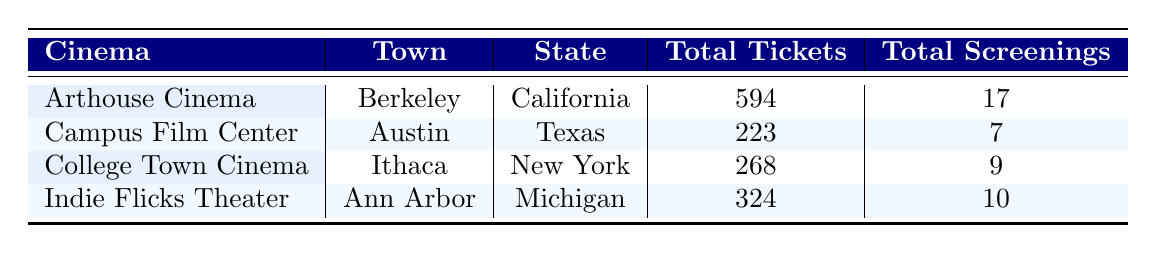What is the total number of tickets sold at Arthouse Cinema? The table shows that Arthouse Cinema sold a total of 594 tickets. This value is directly listed in the table under the "Total Tickets" column for Arthouse Cinema.
Answer: 594 Which cinema had the highest total screenings? By comparing the "Total Screenings" for each cinema, Arthouse Cinema in Berkeley has 17 total screenings, which is higher than the others (Campus Film Center: 7, College Town Cinema: 9, Indie Flicks Theater: 10). Therefore, it had the highest number of screenings.
Answer: Arthouse Cinema How many tickets were sold at Indie Flicks Theater? The table indicates that Indie Flicks Theater sold a total of 324 tickets. This value is found in the "Total Tickets" column corresponding to Indie Flicks Theater.
Answer: 324 What is the average number of tickets sold per screening at College Town Cinema? The average can be calculated by dividing the total tickets sold (268) by the total screenings (9) at College Town Cinema. So the average tickets sold per screening is 268 / 9 = 29.78, which we can round to 30.
Answer: 30 Is the total number of tickets sold at Campus Film Center greater than at Indie Flicks Theater? By checking the total tickets sold, Campus Film Center sold 223 tickets while Indie Flicks Theater sold 324 tickets. Hence, this statement is false.
Answer: No What is the combined total of tickets sold at all cinemas? The total can be calculated by adding the tickets sold at each cinema: 594 (Arthouse) + 223 (Campus) + 268 (College Town) + 324 (Indie Flicks) = 1409. Therefore, the combined total of tickets sold at all cinemas is 1409.
Answer: 1409 Which town has the least total screenings among the cinemas listed? By comparing the total screenings: Ann Arbor (10), Berkeley (17), Austin (7), and Ithaca (9), Austin has the least with 7 screenings.
Answer: Austin Is there a cinema in the state of New York? Yes, the table shows that College Town Cinema is located in Ithaca, New York. Thus, there is indeed a cinema in this state.
Answer: Yes 